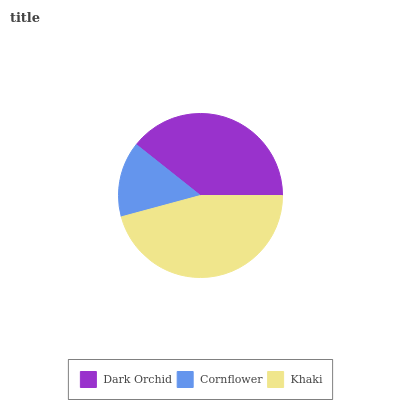Is Cornflower the minimum?
Answer yes or no. Yes. Is Khaki the maximum?
Answer yes or no. Yes. Is Khaki the minimum?
Answer yes or no. No. Is Cornflower the maximum?
Answer yes or no. No. Is Khaki greater than Cornflower?
Answer yes or no. Yes. Is Cornflower less than Khaki?
Answer yes or no. Yes. Is Cornflower greater than Khaki?
Answer yes or no. No. Is Khaki less than Cornflower?
Answer yes or no. No. Is Dark Orchid the high median?
Answer yes or no. Yes. Is Dark Orchid the low median?
Answer yes or no. Yes. Is Cornflower the high median?
Answer yes or no. No. Is Cornflower the low median?
Answer yes or no. No. 